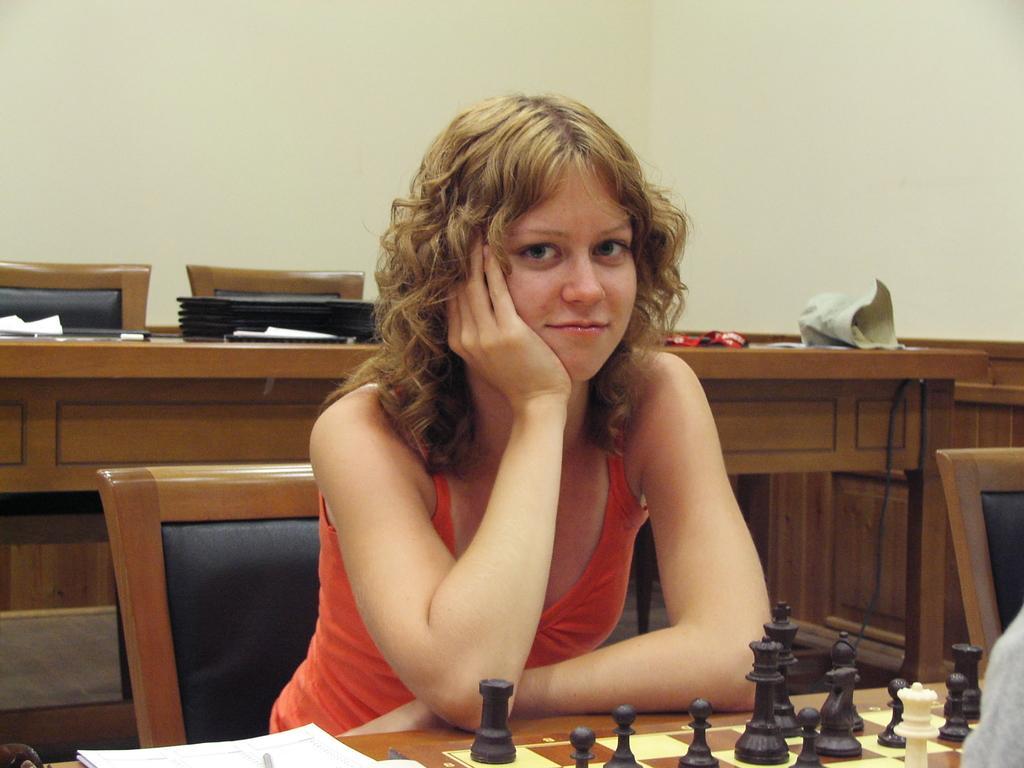Describe this image in one or two sentences. There is a woman sitting in a chair with an orange dress. In Front of her there is a table on which the chess coins and the board is placed. She is placing her hand under her chin. Her hair is yellow in color. In the background we can observe files and a wall here. 